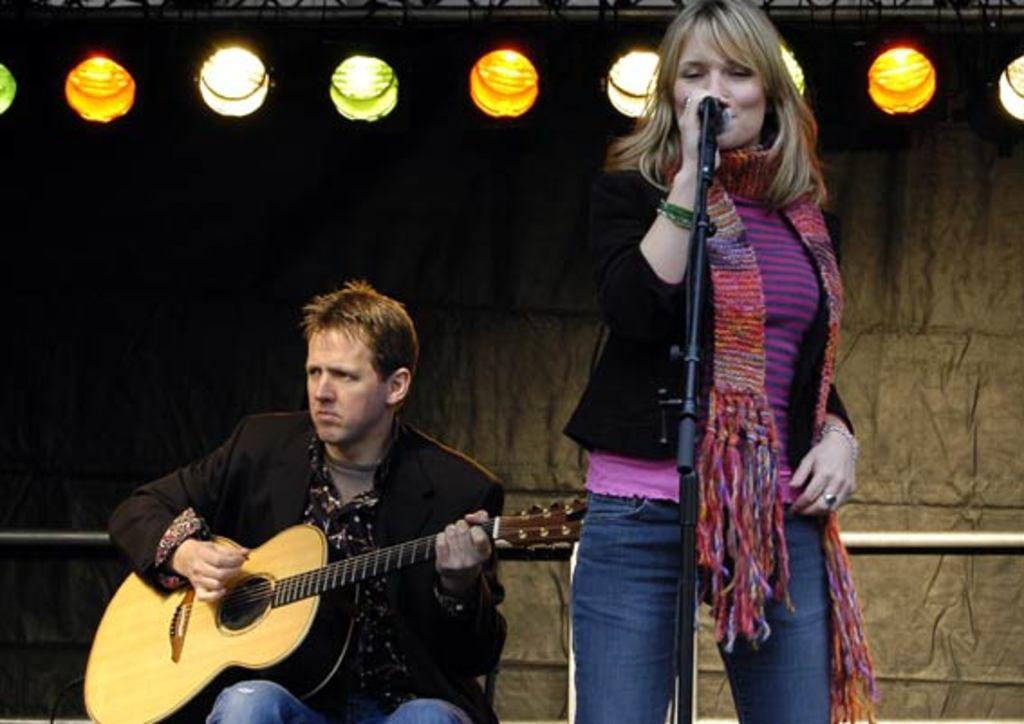What is the man in the image doing? The man is sitting in the image. What is the man holding in his hand? The man is holding a guitar in his hand. What is the position of the woman in the image? The woman is standing in the image. What type of sound can be heard coming from the lake in the image? There is no lake present in the image, so it's not possible to determine what, if any, sounds might be heard. 